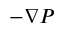<formula> <loc_0><loc_0><loc_500><loc_500>- \nabla P</formula> 